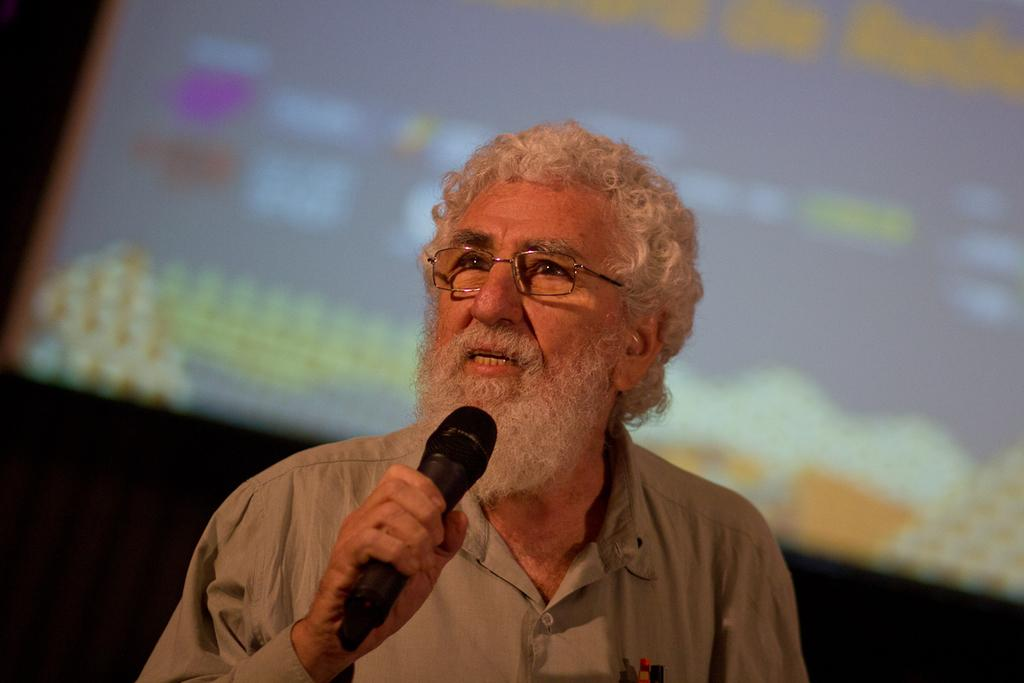What is the main subject in the foreground of the image? There is a man in the foreground of the image. What is the man doing in the image? The man is speaking. Can you describe the background of the image? The background of the man is blurred. Can you tell me how many women are present in the image? There is no woman present in the image; it features a man in the foreground. What type of cord is being used by the man in the image? There is no cord visible in the image; the man is simply speaking. 